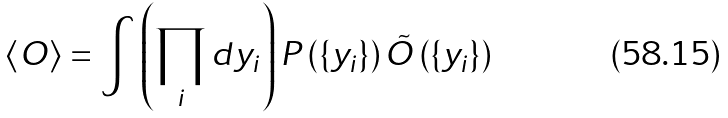<formula> <loc_0><loc_0><loc_500><loc_500>\left \langle O \right \rangle = \int \left ( \prod _ { i } d y _ { i } \right ) P \left ( \{ y _ { i } \} \right ) \tilde { O } \left ( \{ y _ { i } \} \right )</formula> 